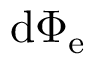<formula> <loc_0><loc_0><loc_500><loc_500>d \Phi _ { e }</formula> 